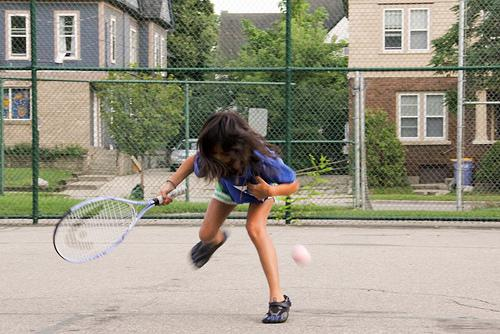Question: where are the girls shoes?
Choices:
A. In her closet.
B. In her room.
C. On the floor.
D. On her feet.
Answer with the letter. Answer: D Question: why is the girl playing?
Choices:
A. Because she's bored.
B. Because she wants to.
C. Because she's interested.
D. Because she can.
Answer with the letter. Answer: B Question: who is behind the girl?
Choices:
A. A man.
B. Nobody.
C. A woman.
D. Her Dog.
Answer with the letter. Answer: B Question: when was the photo taken?
Choices:
A. At night.
B. During the full moon.
C. At dawn.
D. During the day.
Answer with the letter. Answer: D Question: what is the girl holding?
Choices:
A. A doll.
B. A phone.
C. A notebook.
D. Tennis racket.
Answer with the letter. Answer: D 